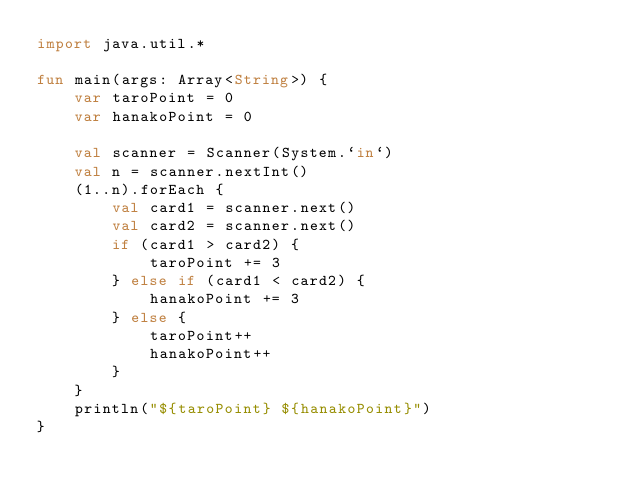Convert code to text. <code><loc_0><loc_0><loc_500><loc_500><_Kotlin_>import java.util.*

fun main(args: Array<String>) {
    var taroPoint = 0
    var hanakoPoint = 0

    val scanner = Scanner(System.`in`)
    val n = scanner.nextInt()
    (1..n).forEach {
        val card1 = scanner.next()
        val card2 = scanner.next()
        if (card1 > card2) {
            taroPoint += 3
        } else if (card1 < card2) {
            hanakoPoint += 3
        } else {
            taroPoint++
            hanakoPoint++
        }
    }
    println("${taroPoint} ${hanakoPoint}")
}
</code> 